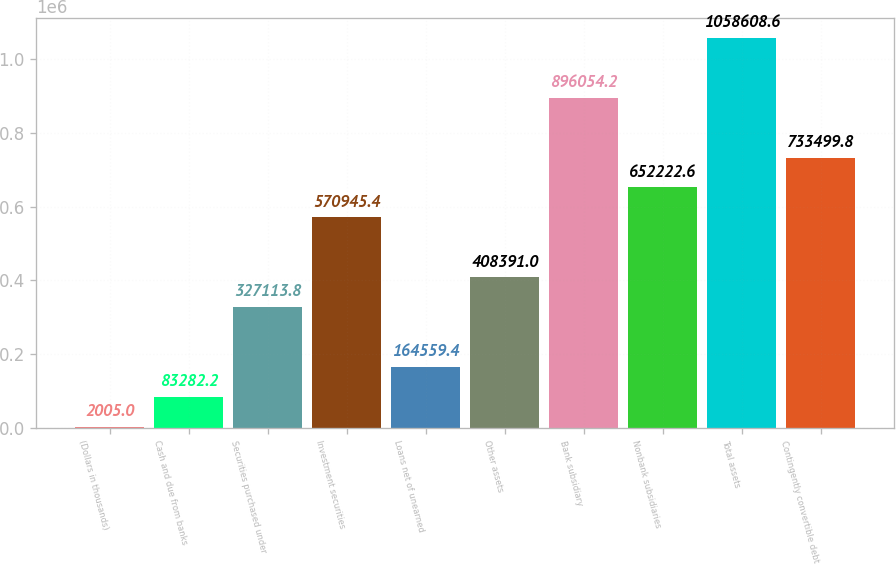<chart> <loc_0><loc_0><loc_500><loc_500><bar_chart><fcel>(Dollars in thousands)<fcel>Cash and due from banks<fcel>Securities purchased under<fcel>Investment securities<fcel>Loans net of unearned<fcel>Other assets<fcel>Bank subsidiary<fcel>Nonbank subsidiaries<fcel>Total assets<fcel>Contingently convertible debt<nl><fcel>2005<fcel>83282.2<fcel>327114<fcel>570945<fcel>164559<fcel>408391<fcel>896054<fcel>652223<fcel>1.05861e+06<fcel>733500<nl></chart> 